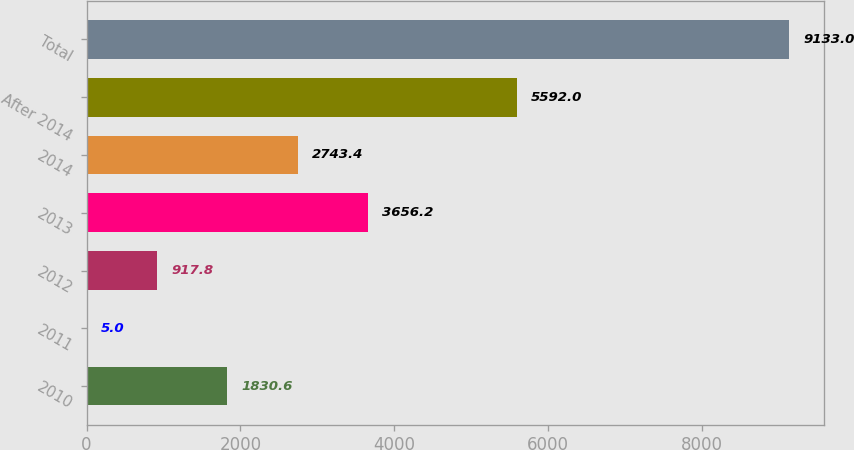Convert chart. <chart><loc_0><loc_0><loc_500><loc_500><bar_chart><fcel>2010<fcel>2011<fcel>2012<fcel>2013<fcel>2014<fcel>After 2014<fcel>Total<nl><fcel>1830.6<fcel>5<fcel>917.8<fcel>3656.2<fcel>2743.4<fcel>5592<fcel>9133<nl></chart> 